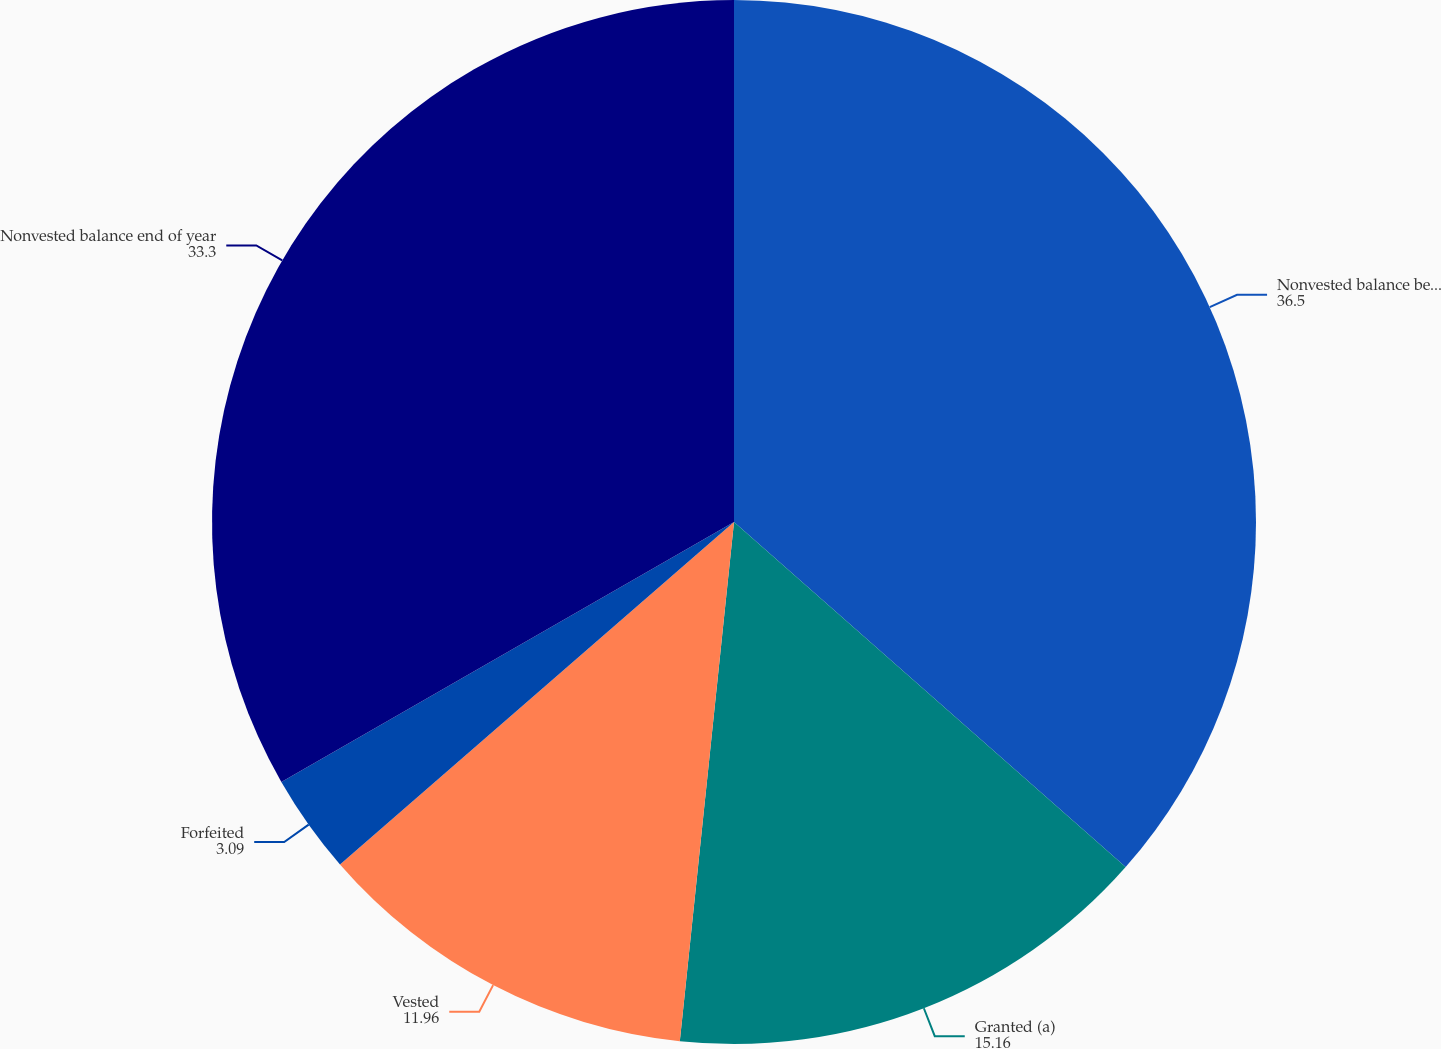Convert chart. <chart><loc_0><loc_0><loc_500><loc_500><pie_chart><fcel>Nonvested balance beginning of<fcel>Granted (a)<fcel>Vested<fcel>Forfeited<fcel>Nonvested balance end of year<nl><fcel>36.5%<fcel>15.16%<fcel>11.96%<fcel>3.09%<fcel>33.3%<nl></chart> 